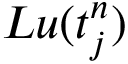<formula> <loc_0><loc_0><loc_500><loc_500>L u ( t _ { j } ^ { n } )</formula> 